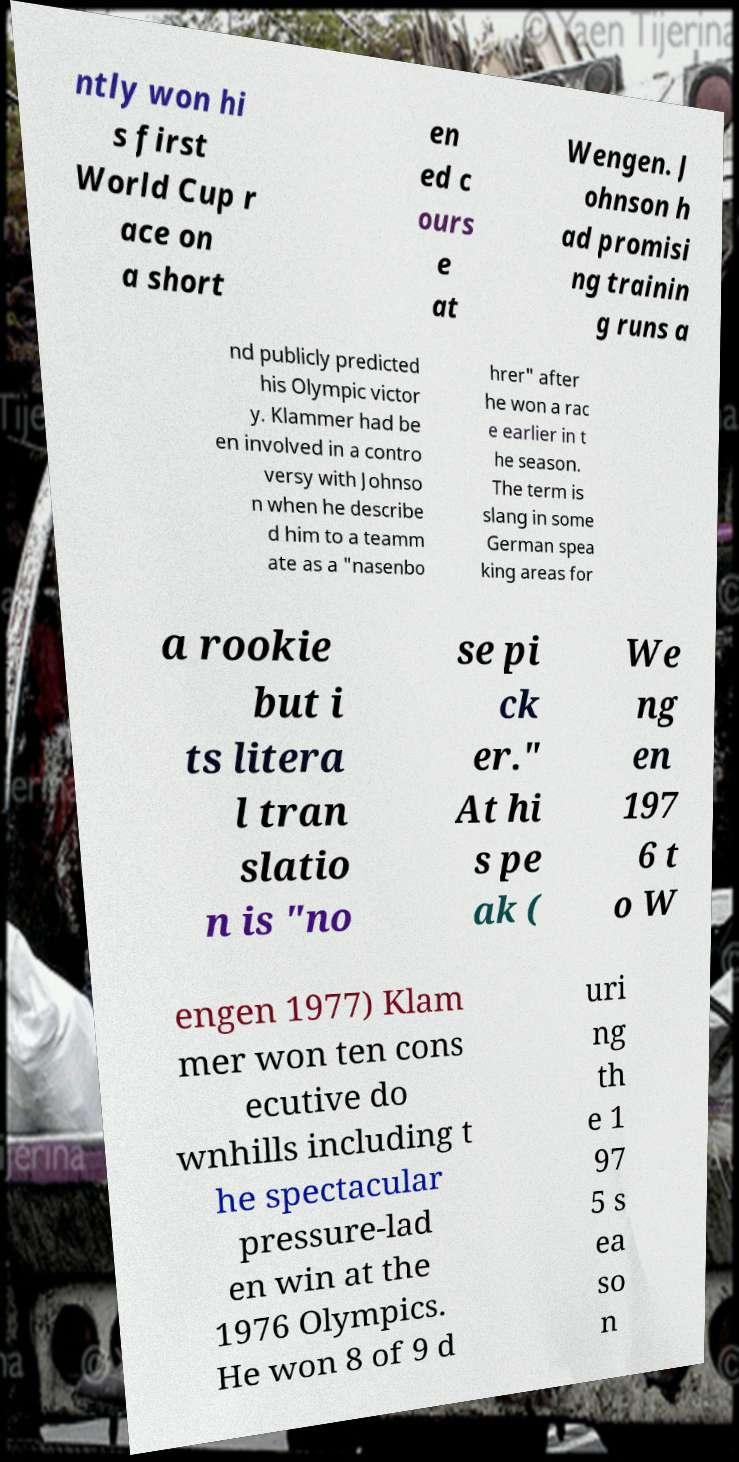Could you extract and type out the text from this image? ntly won hi s first World Cup r ace on a short en ed c ours e at Wengen. J ohnson h ad promisi ng trainin g runs a nd publicly predicted his Olympic victor y. Klammer had be en involved in a contro versy with Johnso n when he describe d him to a teamm ate as a "nasenbo hrer" after he won a rac e earlier in t he season. The term is slang in some German spea king areas for a rookie but i ts litera l tran slatio n is "no se pi ck er." At hi s pe ak ( We ng en 197 6 t o W engen 1977) Klam mer won ten cons ecutive do wnhills including t he spectacular pressure-lad en win at the 1976 Olympics. He won 8 of 9 d uri ng th e 1 97 5 s ea so n 